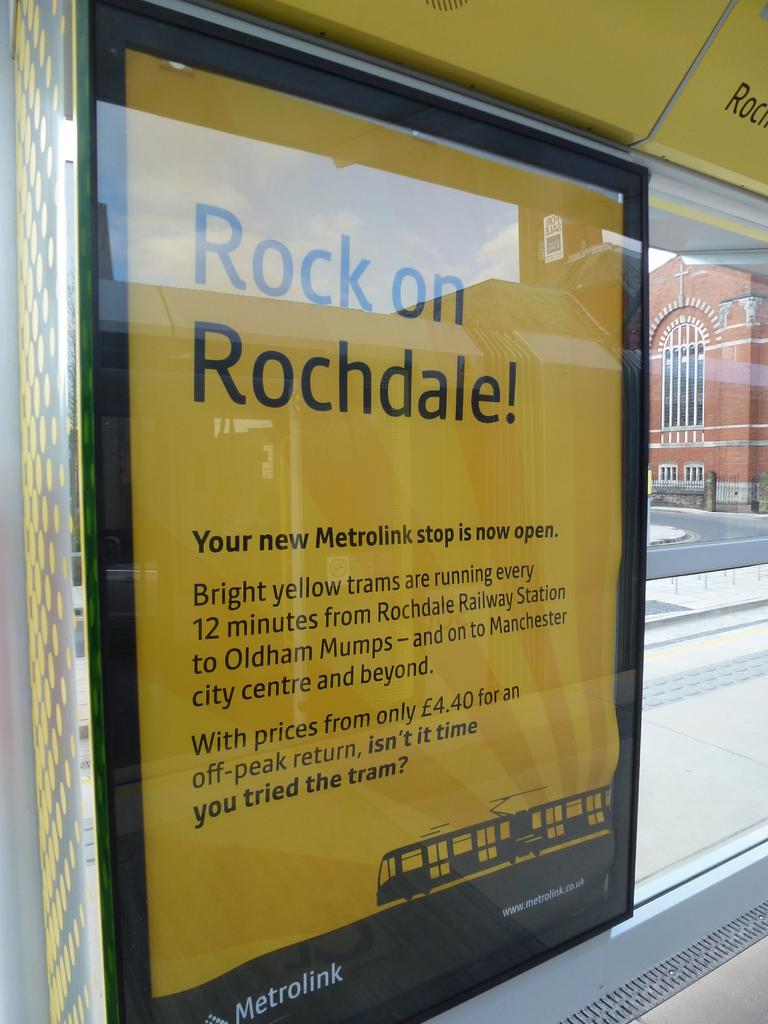<image>
Give a short and clear explanation of the subsequent image. A yellow and black sign on the Metrolink that says Rock On Rochdale. 